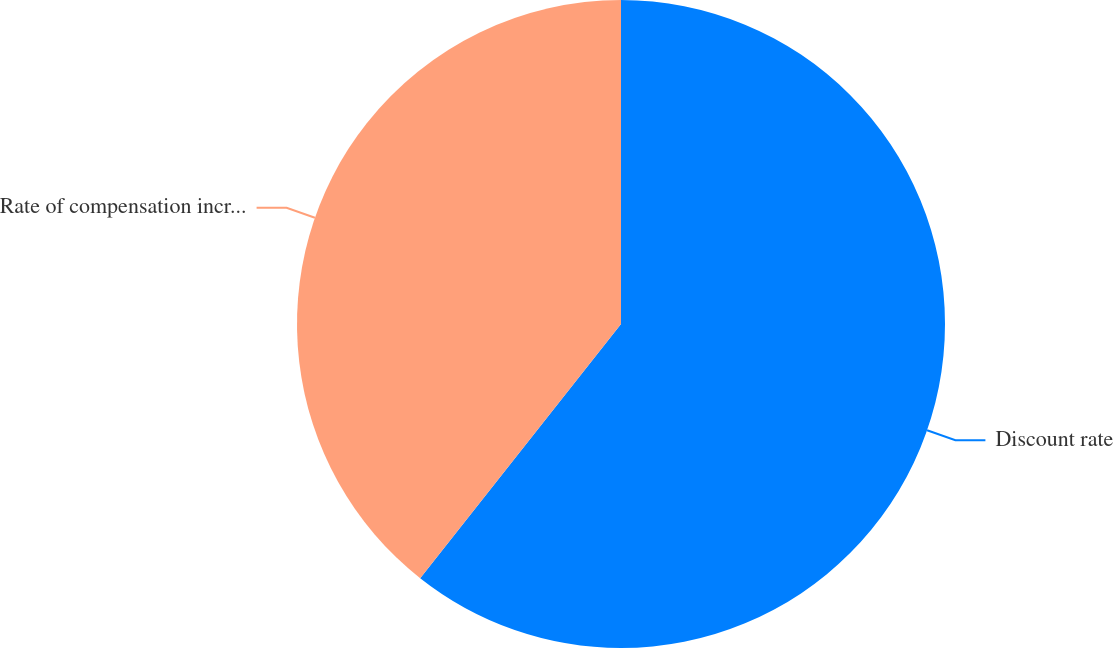<chart> <loc_0><loc_0><loc_500><loc_500><pie_chart><fcel>Discount rate<fcel>Rate of compensation increase<nl><fcel>60.64%<fcel>39.36%<nl></chart> 